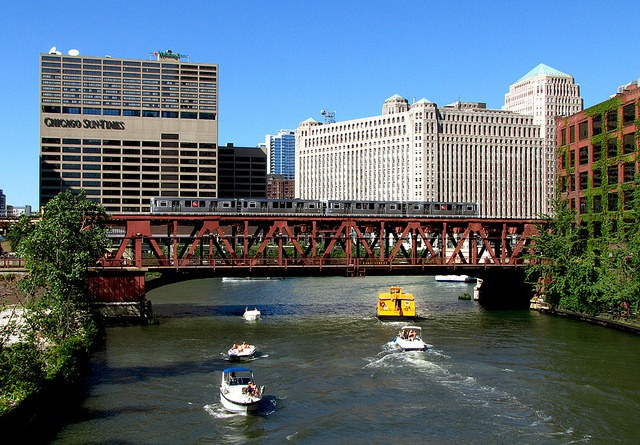Describe the objects in this image and their specific colors. I can see train in lightblue, gray, black, and darkgray tones, boat in lightblue, black, white, gray, and purple tones, boat in lightblue, gold, black, and orange tones, boat in lightblue, white, gray, black, and darkgreen tones, and boat in lightblue, white, black, darkgray, and gray tones in this image. 